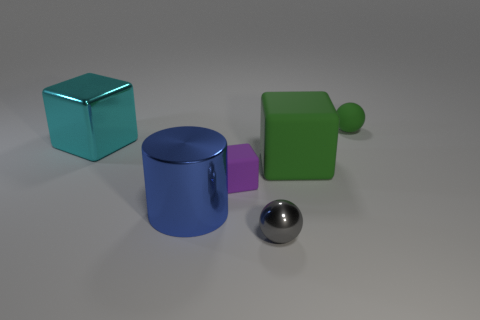Can you tell me which objects are touching each other? The blue cube and purple cylinder are in contact, with the cylinder lying on its side against the cube. The large green block does not seem to be touching any other object, and neither does the small green sphere.  What can you infer about the textures of the objects? The objects appear to have varying textures: the blue cube and purple cylinder have a semblance of a shiny, metallic texture, whereas the large green block and small green sphere look like they have a matte, possibly rubbery texture. 